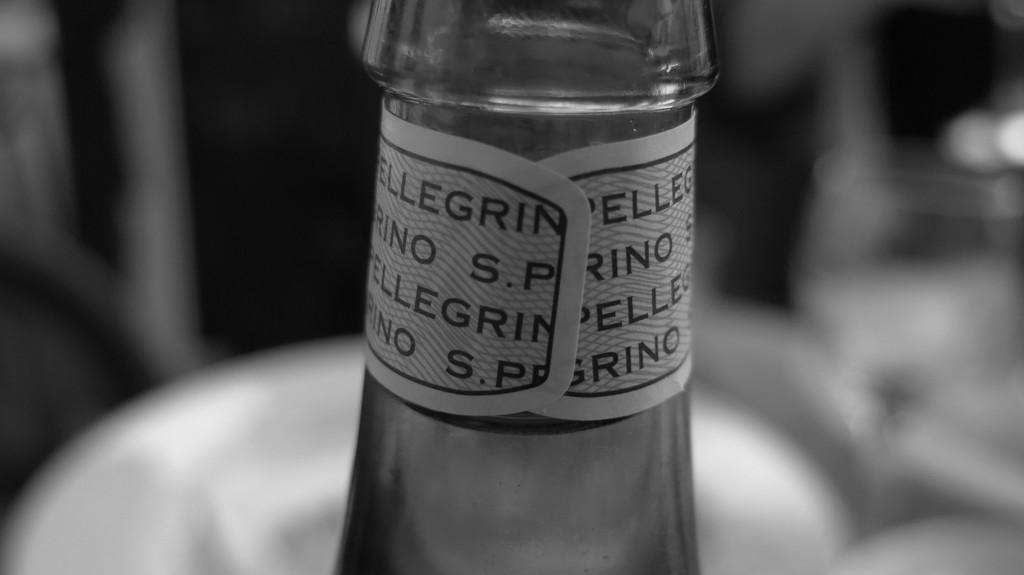What is the color scheme of the image? The image is black and white. What object is present in the image? There is a glass bottle in the image. What can be found on the glass bottle? The glass bottle has a label. Can you describe the background of the image? The background of the image is blurred. What is the title of the book on the table in the image? There is no book or table present in the image; it only features a black and white glass bottle with a label. How many cattle can be seen grazing in the background of the image? There are no cattle present in the image; the background is blurred. 